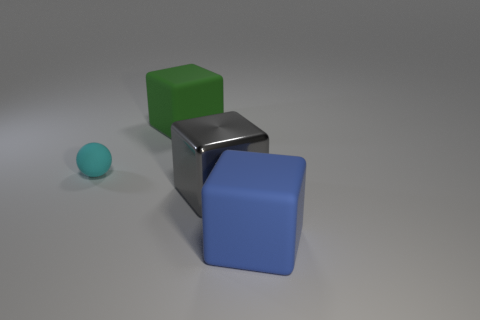Add 1 tiny metal things. How many objects exist? 5 Subtract all spheres. How many objects are left? 3 Subtract all small purple things. Subtract all large gray shiny things. How many objects are left? 3 Add 2 gray objects. How many gray objects are left? 3 Add 3 gray metallic blocks. How many gray metallic blocks exist? 4 Subtract 0 yellow cylinders. How many objects are left? 4 